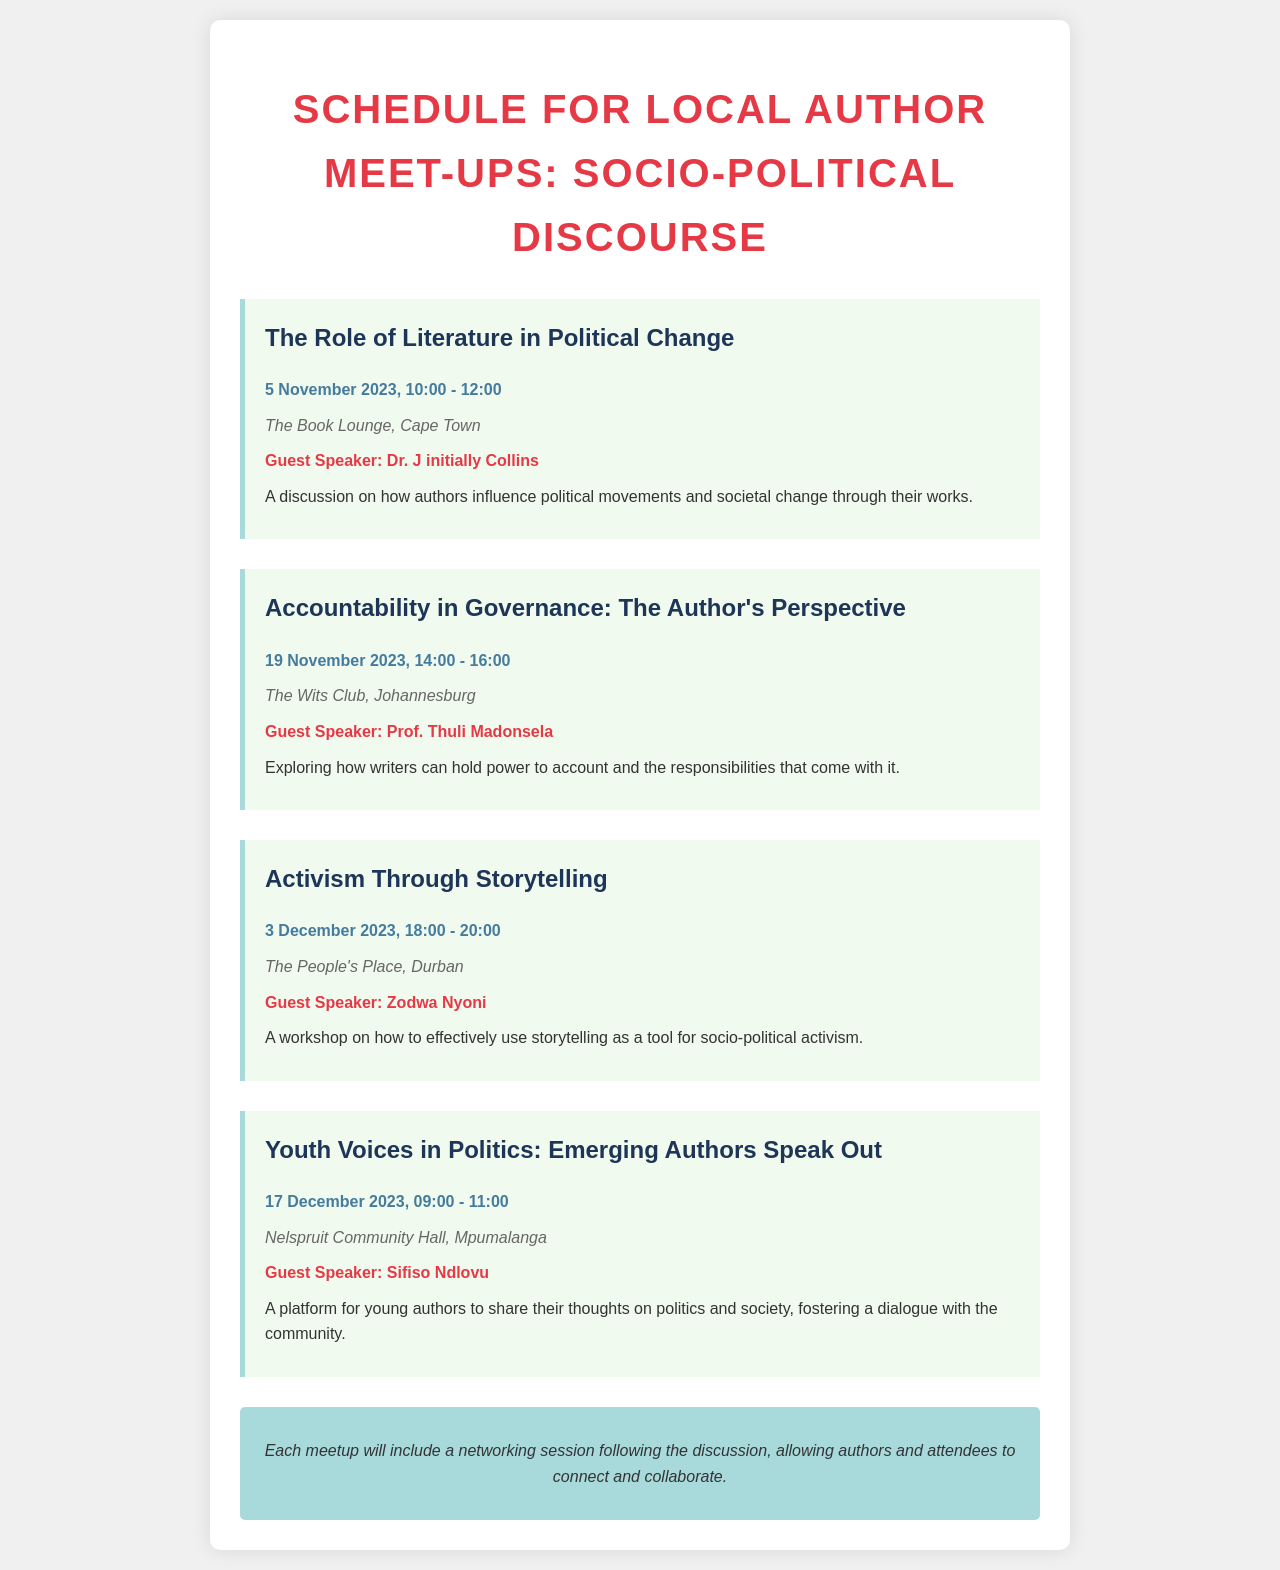What is the first meetup topic? The first meetup topic is the title of the event listed at the top of the schedule.
Answer: The Role of Literature in Political Change Who is the guest speaker for the second meetup? The speaker name can be found in the section for the second meetup.
Answer: Prof. Thuli Madonsela What is the location of the third meetup? The location can be found under the date and time for the third meetup.
Answer: The People's Place, Durban When is the last meetup scheduled? The date and time for the last meetup is provided at the end of the list.
Answer: 17 December 2023, 09:00 - 11:00 How many meetups are scheduled in total? The total number of meetups can be counted in the document.
Answer: Four Which meetup focuses on youth authors? The specific topic regarding youth authors can be identified in the title of the relevant meetup.
Answer: Youth Voices in Politics: Emerging Authors Speak Out What is the common theme across all meetups? The common theme of the document is inferred from the series of topics covered in the meetup titles.
Answer: Socio-Political Discourse What is included after each meetup? The additional activity following each meetup is mentioned in the concluding note of the document.
Answer: Networking session 